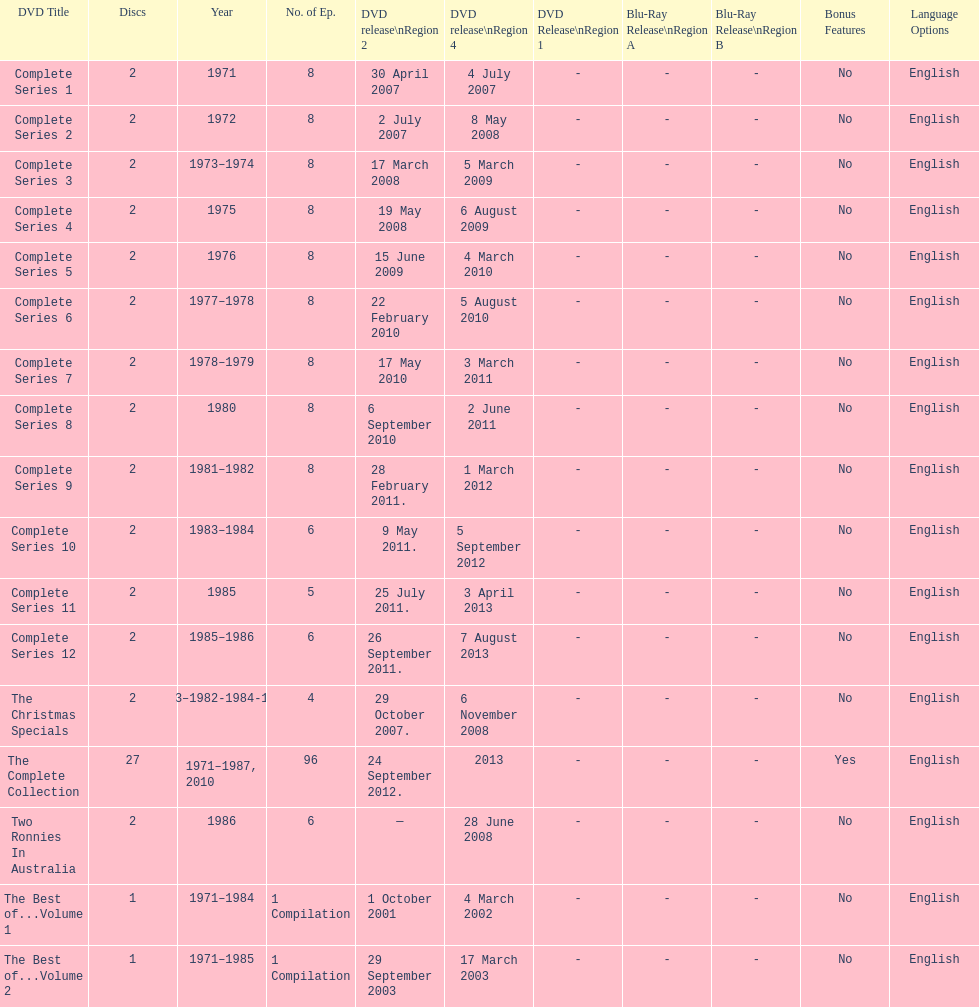In regards to the tv show "the two ronnies," how many "best of" volumes have been created to compile the top episodes? 2. 